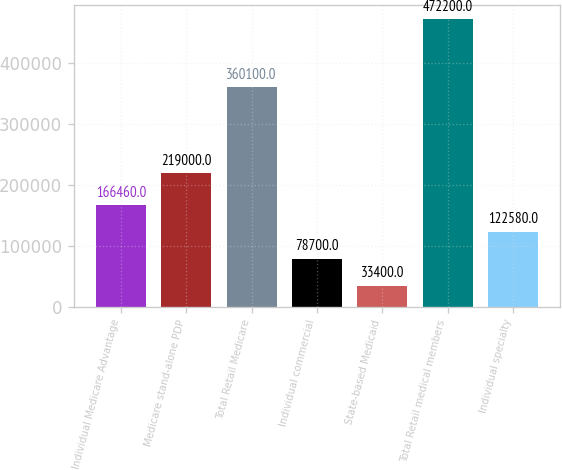Convert chart. <chart><loc_0><loc_0><loc_500><loc_500><bar_chart><fcel>Individual Medicare Advantage<fcel>Medicare stand-alone PDP<fcel>Total Retail Medicare<fcel>Individual commercial<fcel>State-based Medicaid<fcel>Total Retail medical members<fcel>Individual specialty<nl><fcel>166460<fcel>219000<fcel>360100<fcel>78700<fcel>33400<fcel>472200<fcel>122580<nl></chart> 